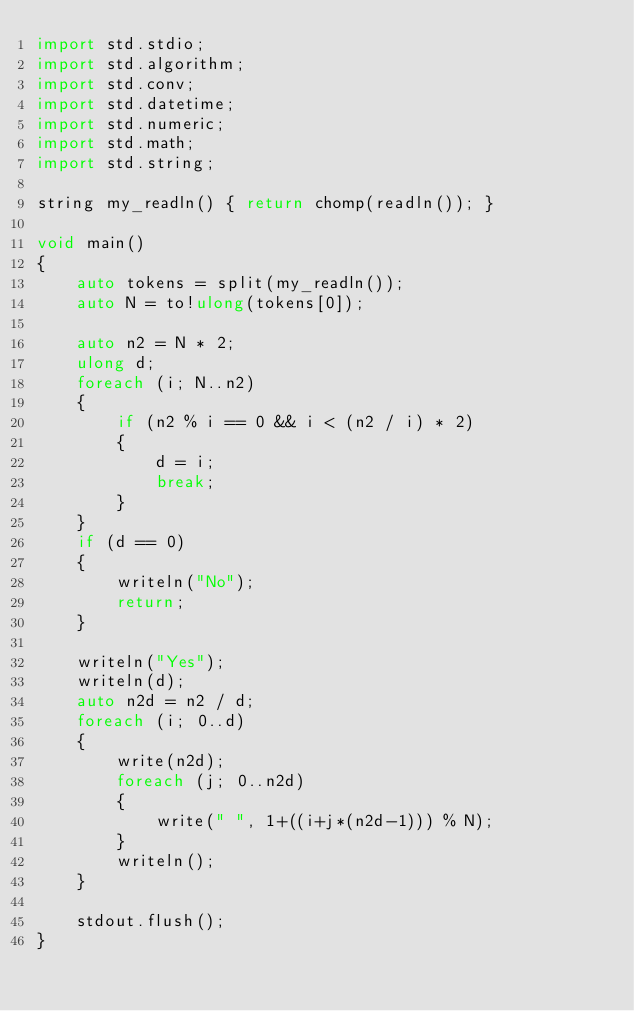<code> <loc_0><loc_0><loc_500><loc_500><_D_>import std.stdio;
import std.algorithm;
import std.conv;
import std.datetime;
import std.numeric;
import std.math;
import std.string;

string my_readln() { return chomp(readln()); }

void main()
{
	auto tokens = split(my_readln());
	auto N = to!ulong(tokens[0]);

	auto n2 = N * 2;
	ulong d;
	foreach (i; N..n2)
	{
		if (n2 % i == 0 && i < (n2 / i) * 2)
		{
			d = i;
			break;
		}
	}
	if (d == 0)
	{
		writeln("No");
		return;
	}

	writeln("Yes");
	writeln(d);
	auto n2d = n2 / d;
	foreach (i; 0..d)
	{
		write(n2d);
		foreach (j; 0..n2d)
		{
			write(" ", 1+((i+j*(n2d-1))) % N);
		}
		writeln();
	}
	
	stdout.flush();
}</code> 